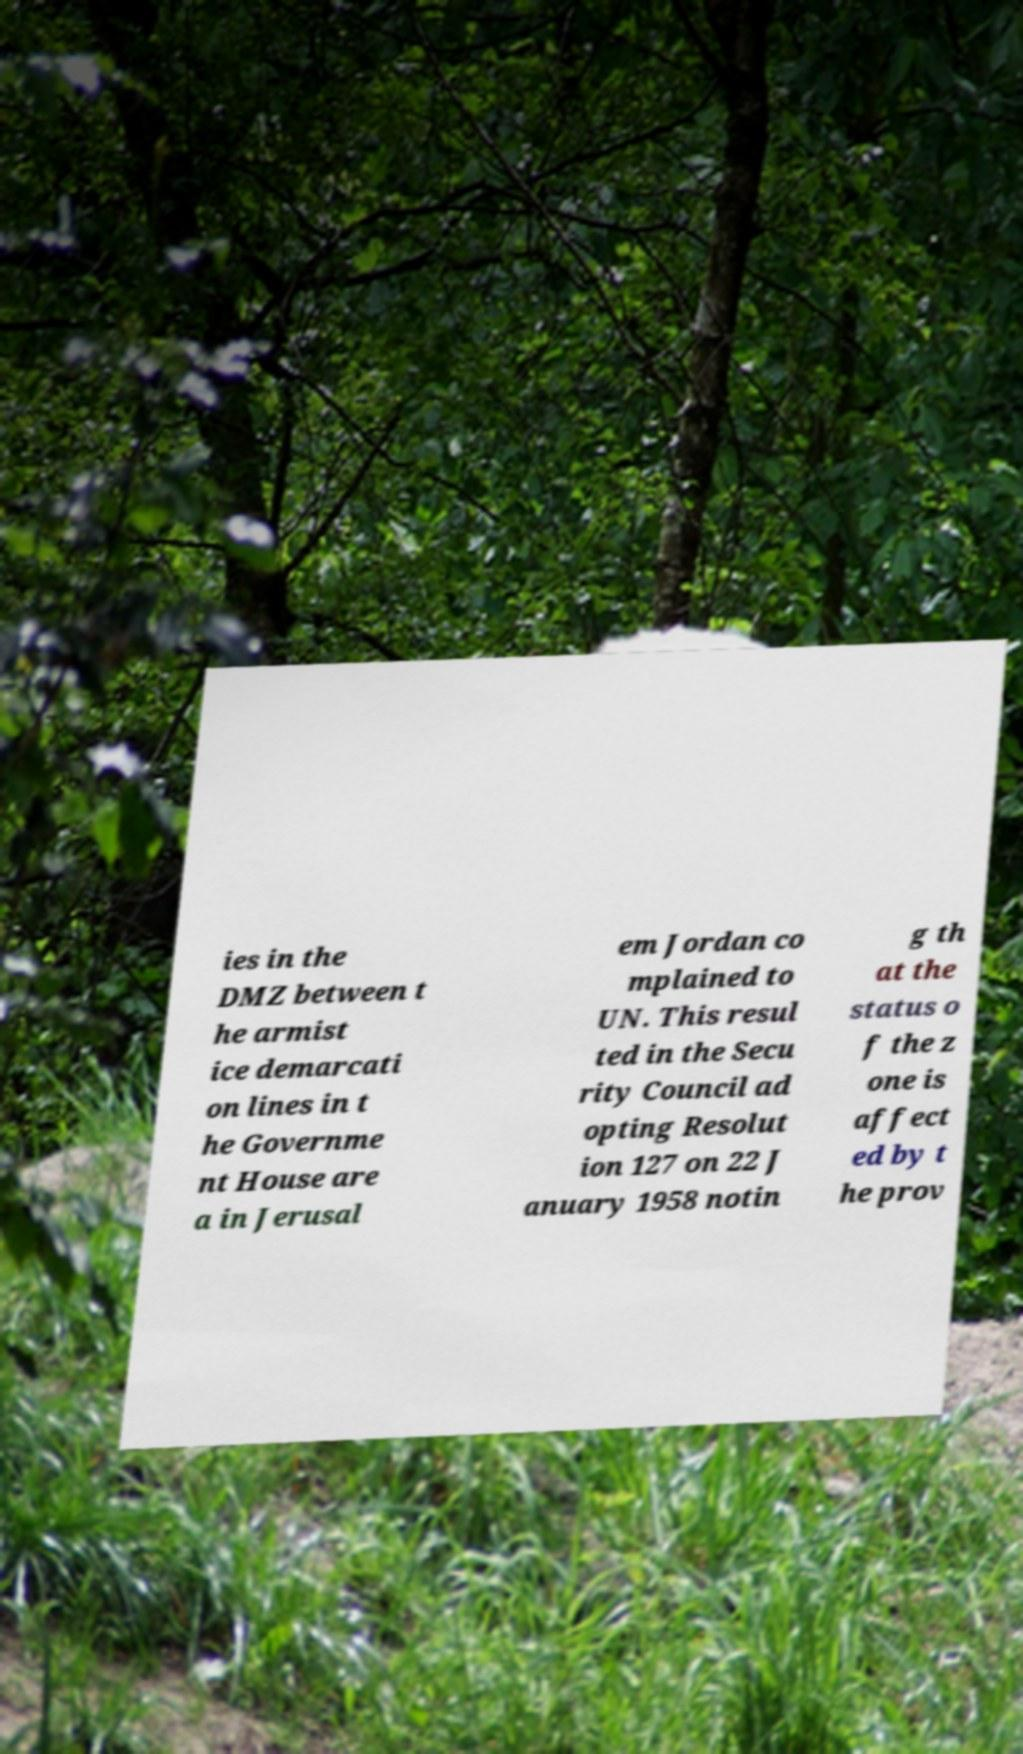For documentation purposes, I need the text within this image transcribed. Could you provide that? ies in the DMZ between t he armist ice demarcati on lines in t he Governme nt House are a in Jerusal em Jordan co mplained to UN. This resul ted in the Secu rity Council ad opting Resolut ion 127 on 22 J anuary 1958 notin g th at the status o f the z one is affect ed by t he prov 